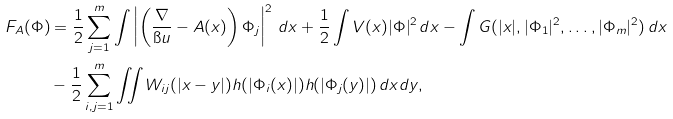<formula> <loc_0><loc_0><loc_500><loc_500>F _ { A } ( \Phi ) & = \frac { 1 } { 2 } \sum _ { j = 1 } ^ { m } \int \left | \left ( \frac { \nabla } { \i u } - A ( x ) \right ) \Phi _ { j } \right | ^ { 2 } \, d x + \frac { 1 } { 2 } \int V ( x ) | \Phi | ^ { 2 } \, d x - \int G ( | x | , | \Phi _ { 1 } | ^ { 2 } , \dots , | \Phi _ { m } | ^ { 2 } ) \, d x \\ & - \frac { 1 } { 2 } \sum _ { i , j = 1 } ^ { m } \iint W _ { i j } ( | x - y | ) h ( | \Phi _ { i } ( x ) | ) h ( | \Phi _ { j } ( y ) | ) \, d x d y ,</formula> 